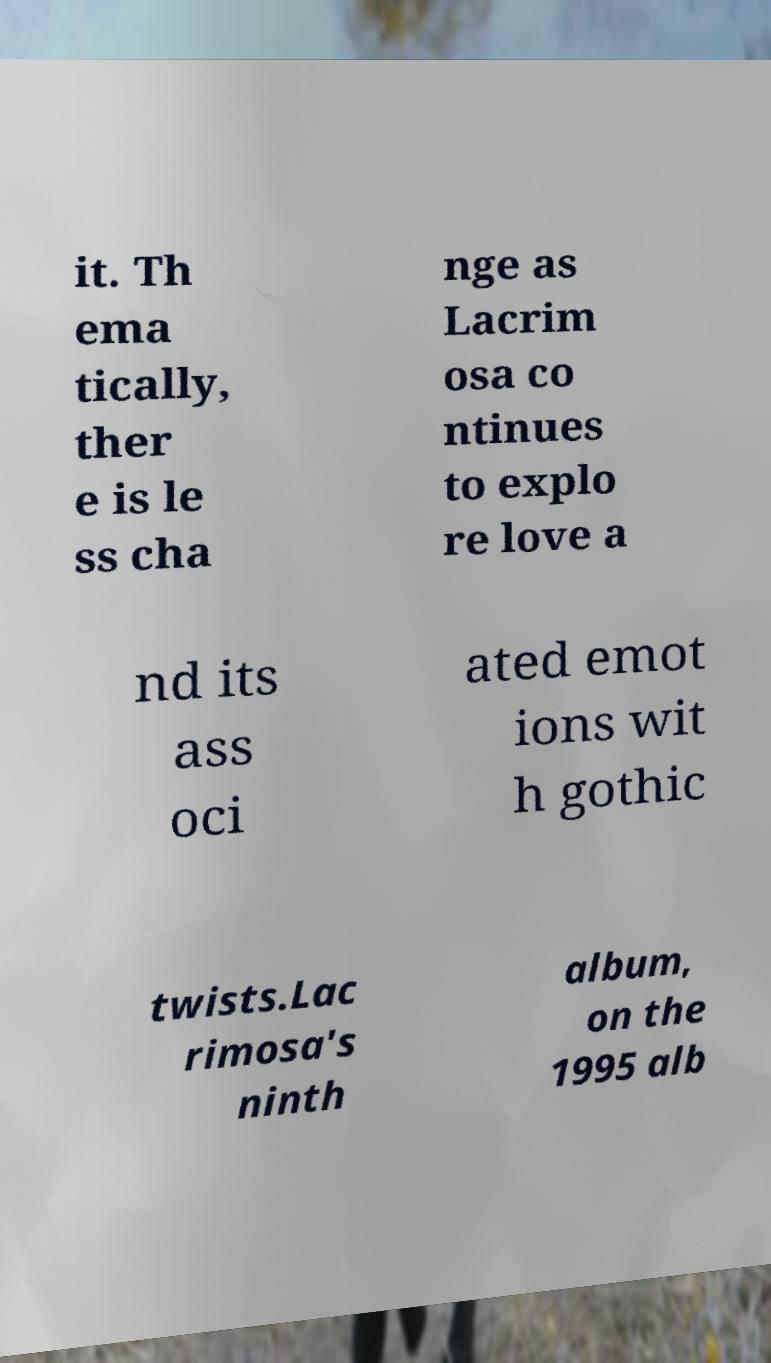There's text embedded in this image that I need extracted. Can you transcribe it verbatim? it. Th ema tically, ther e is le ss cha nge as Lacrim osa co ntinues to explo re love a nd its ass oci ated emot ions wit h gothic twists.Lac rimosa's ninth album, on the 1995 alb 